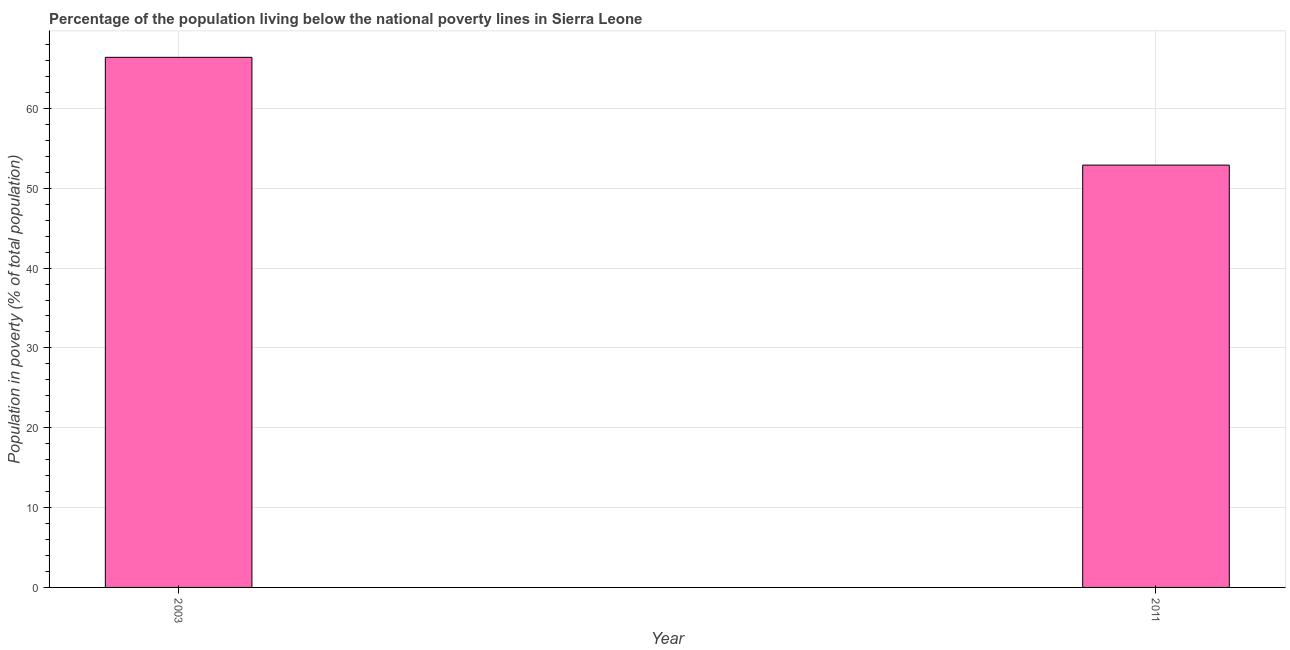Does the graph contain grids?
Give a very brief answer. Yes. What is the title of the graph?
Your response must be concise. Percentage of the population living below the national poverty lines in Sierra Leone. What is the label or title of the X-axis?
Make the answer very short. Year. What is the label or title of the Y-axis?
Give a very brief answer. Population in poverty (% of total population). What is the percentage of population living below poverty line in 2011?
Offer a very short reply. 52.9. Across all years, what is the maximum percentage of population living below poverty line?
Your answer should be very brief. 66.4. Across all years, what is the minimum percentage of population living below poverty line?
Provide a short and direct response. 52.9. In which year was the percentage of population living below poverty line maximum?
Keep it short and to the point. 2003. In which year was the percentage of population living below poverty line minimum?
Your answer should be compact. 2011. What is the sum of the percentage of population living below poverty line?
Make the answer very short. 119.3. What is the difference between the percentage of population living below poverty line in 2003 and 2011?
Provide a short and direct response. 13.5. What is the average percentage of population living below poverty line per year?
Keep it short and to the point. 59.65. What is the median percentage of population living below poverty line?
Provide a short and direct response. 59.65. In how many years, is the percentage of population living below poverty line greater than 24 %?
Give a very brief answer. 2. What is the ratio of the percentage of population living below poverty line in 2003 to that in 2011?
Provide a short and direct response. 1.25. Is the percentage of population living below poverty line in 2003 less than that in 2011?
Give a very brief answer. No. What is the difference between two consecutive major ticks on the Y-axis?
Provide a succinct answer. 10. What is the Population in poverty (% of total population) of 2003?
Offer a very short reply. 66.4. What is the Population in poverty (% of total population) of 2011?
Offer a terse response. 52.9. What is the difference between the Population in poverty (% of total population) in 2003 and 2011?
Your response must be concise. 13.5. What is the ratio of the Population in poverty (% of total population) in 2003 to that in 2011?
Provide a succinct answer. 1.25. 